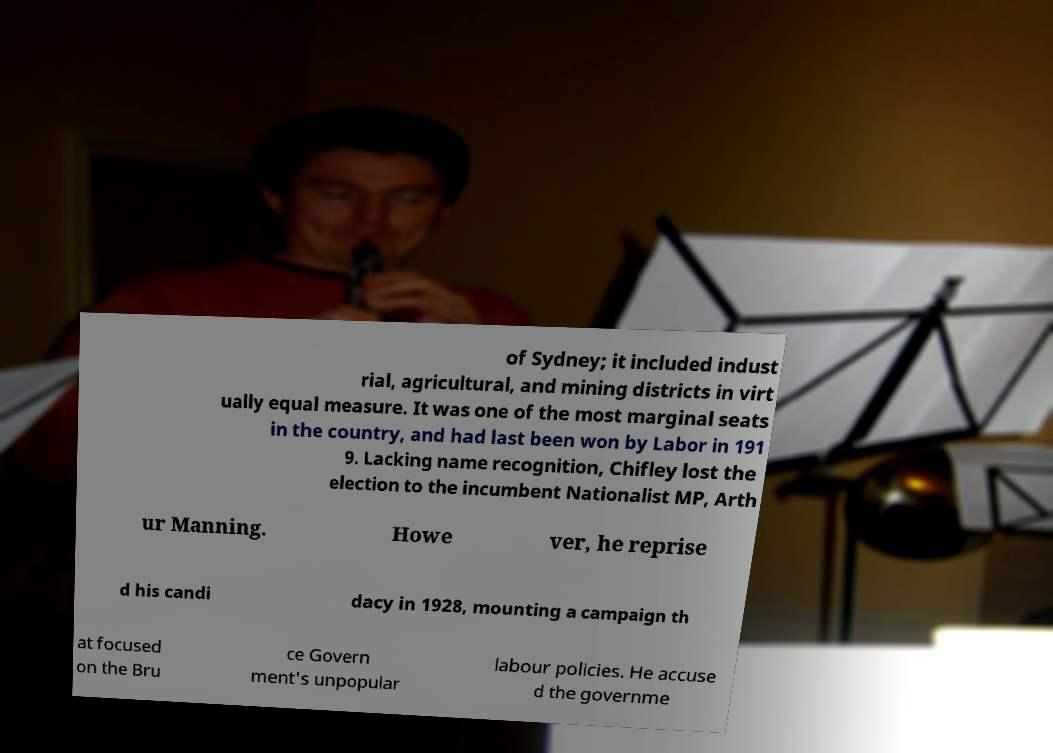Could you extract and type out the text from this image? of Sydney; it included indust rial, agricultural, and mining districts in virt ually equal measure. It was one of the most marginal seats in the country, and had last been won by Labor in 191 9. Lacking name recognition, Chifley lost the election to the incumbent Nationalist MP, Arth ur Manning. Howe ver, he reprise d his candi dacy in 1928, mounting a campaign th at focused on the Bru ce Govern ment's unpopular labour policies. He accuse d the governme 